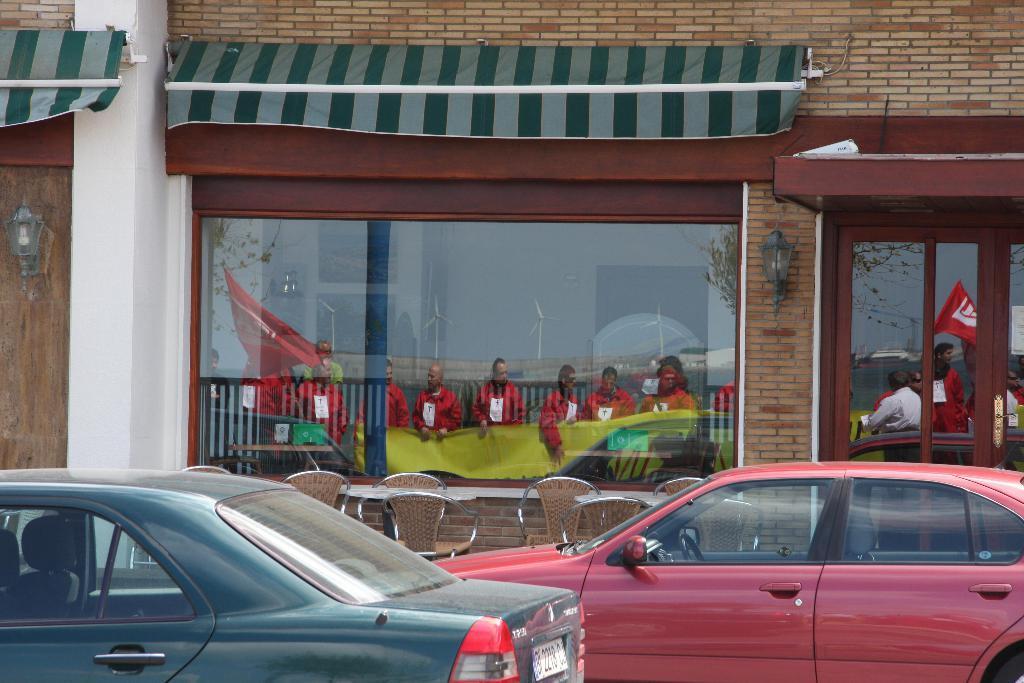Please provide a concise description of this image. On the left side, there is a vehicle on a road. On the right side, there is a red color vehicle on the road. In the background, there are tables and chairs arranged and there is a building having glass doors and windows. On these glass doors and windows, we can see there are mirror images of persons in red color shirts, a fence, wind fans and trees. 